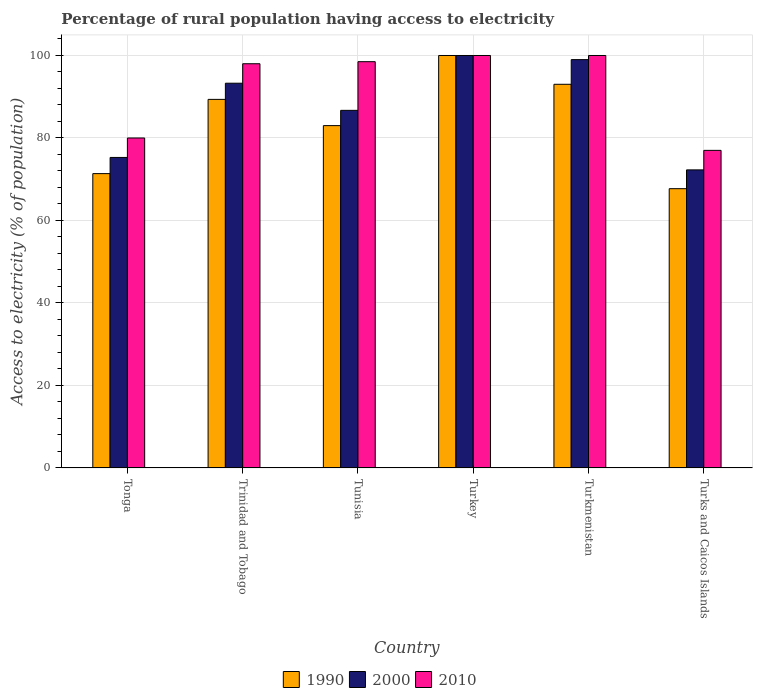How many different coloured bars are there?
Make the answer very short. 3. How many groups of bars are there?
Your answer should be very brief. 6. Are the number of bars per tick equal to the number of legend labels?
Offer a terse response. Yes. Are the number of bars on each tick of the X-axis equal?
Offer a terse response. Yes. What is the label of the 4th group of bars from the left?
Ensure brevity in your answer.  Turkey. In how many cases, is the number of bars for a given country not equal to the number of legend labels?
Your response must be concise. 0. What is the percentage of rural population having access to electricity in 1990 in Tunisia?
Offer a terse response. 83. Across all countries, what is the maximum percentage of rural population having access to electricity in 2010?
Make the answer very short. 100. Across all countries, what is the minimum percentage of rural population having access to electricity in 1990?
Ensure brevity in your answer.  67.71. In which country was the percentage of rural population having access to electricity in 1990 maximum?
Your answer should be very brief. Turkey. In which country was the percentage of rural population having access to electricity in 1990 minimum?
Your answer should be compact. Turks and Caicos Islands. What is the total percentage of rural population having access to electricity in 1990 in the graph?
Make the answer very short. 504.45. What is the difference between the percentage of rural population having access to electricity in 1990 in Tunisia and that in Turks and Caicos Islands?
Give a very brief answer. 15.29. What is the difference between the percentage of rural population having access to electricity in 2000 in Turks and Caicos Islands and the percentage of rural population having access to electricity in 1990 in Tonga?
Make the answer very short. 0.9. What is the average percentage of rural population having access to electricity in 2010 per country?
Offer a terse response. 92.25. In how many countries, is the percentage of rural population having access to electricity in 2010 greater than 96 %?
Your response must be concise. 4. What is the ratio of the percentage of rural population having access to electricity in 1990 in Tunisia to that in Turkey?
Keep it short and to the point. 0.83. Is the percentage of rural population having access to electricity in 1990 in Tunisia less than that in Turkmenistan?
Keep it short and to the point. Yes. What is the difference between the highest and the second highest percentage of rural population having access to electricity in 2010?
Keep it short and to the point. -1.5. In how many countries, is the percentage of rural population having access to electricity in 2000 greater than the average percentage of rural population having access to electricity in 2000 taken over all countries?
Provide a short and direct response. 3. Is the sum of the percentage of rural population having access to electricity in 2010 in Trinidad and Tobago and Tunisia greater than the maximum percentage of rural population having access to electricity in 2000 across all countries?
Make the answer very short. Yes. What does the 1st bar from the left in Tonga represents?
Make the answer very short. 1990. What does the 2nd bar from the right in Turkey represents?
Your answer should be compact. 2000. Is it the case that in every country, the sum of the percentage of rural population having access to electricity in 2000 and percentage of rural population having access to electricity in 2010 is greater than the percentage of rural population having access to electricity in 1990?
Ensure brevity in your answer.  Yes. Where does the legend appear in the graph?
Offer a terse response. Bottom center. How many legend labels are there?
Provide a short and direct response. 3. How are the legend labels stacked?
Offer a terse response. Horizontal. What is the title of the graph?
Provide a short and direct response. Percentage of rural population having access to electricity. What is the label or title of the X-axis?
Your response must be concise. Country. What is the label or title of the Y-axis?
Keep it short and to the point. Access to electricity (% of population). What is the Access to electricity (% of population) in 1990 in Tonga?
Your answer should be very brief. 71.36. What is the Access to electricity (% of population) of 2000 in Tonga?
Offer a terse response. 75.28. What is the Access to electricity (% of population) in 1990 in Trinidad and Tobago?
Give a very brief answer. 89.36. What is the Access to electricity (% of population) in 2000 in Trinidad and Tobago?
Your answer should be compact. 93.28. What is the Access to electricity (% of population) in 2010 in Trinidad and Tobago?
Give a very brief answer. 98. What is the Access to electricity (% of population) in 1990 in Tunisia?
Offer a terse response. 83. What is the Access to electricity (% of population) of 2000 in Tunisia?
Give a very brief answer. 86.7. What is the Access to electricity (% of population) in 2010 in Tunisia?
Your response must be concise. 98.5. What is the Access to electricity (% of population) of 2010 in Turkey?
Offer a very short reply. 100. What is the Access to electricity (% of population) in 1990 in Turkmenistan?
Give a very brief answer. 93.02. What is the Access to electricity (% of population) of 1990 in Turks and Caicos Islands?
Provide a succinct answer. 67.71. What is the Access to electricity (% of population) in 2000 in Turks and Caicos Islands?
Offer a terse response. 72.27. Across all countries, what is the maximum Access to electricity (% of population) of 1990?
Offer a terse response. 100. Across all countries, what is the maximum Access to electricity (% of population) in 2010?
Keep it short and to the point. 100. Across all countries, what is the minimum Access to electricity (% of population) in 1990?
Offer a very short reply. 67.71. Across all countries, what is the minimum Access to electricity (% of population) in 2000?
Offer a terse response. 72.27. What is the total Access to electricity (% of population) of 1990 in the graph?
Your answer should be compact. 504.45. What is the total Access to electricity (% of population) of 2000 in the graph?
Give a very brief answer. 526.53. What is the total Access to electricity (% of population) in 2010 in the graph?
Your answer should be very brief. 553.5. What is the difference between the Access to electricity (% of population) of 2000 in Tonga and that in Trinidad and Tobago?
Your response must be concise. -18. What is the difference between the Access to electricity (% of population) of 2010 in Tonga and that in Trinidad and Tobago?
Your answer should be very brief. -18. What is the difference between the Access to electricity (% of population) in 1990 in Tonga and that in Tunisia?
Ensure brevity in your answer.  -11.64. What is the difference between the Access to electricity (% of population) in 2000 in Tonga and that in Tunisia?
Keep it short and to the point. -11.42. What is the difference between the Access to electricity (% of population) in 2010 in Tonga and that in Tunisia?
Your answer should be very brief. -18.5. What is the difference between the Access to electricity (% of population) of 1990 in Tonga and that in Turkey?
Ensure brevity in your answer.  -28.64. What is the difference between the Access to electricity (% of population) of 2000 in Tonga and that in Turkey?
Provide a short and direct response. -24.72. What is the difference between the Access to electricity (% of population) of 2010 in Tonga and that in Turkey?
Offer a very short reply. -20. What is the difference between the Access to electricity (% of population) of 1990 in Tonga and that in Turkmenistan?
Provide a short and direct response. -21.66. What is the difference between the Access to electricity (% of population) in 2000 in Tonga and that in Turkmenistan?
Give a very brief answer. -23.72. What is the difference between the Access to electricity (% of population) in 2010 in Tonga and that in Turkmenistan?
Ensure brevity in your answer.  -20. What is the difference between the Access to electricity (% of population) in 1990 in Tonga and that in Turks and Caicos Islands?
Offer a terse response. 3.65. What is the difference between the Access to electricity (% of population) of 2000 in Tonga and that in Turks and Caicos Islands?
Ensure brevity in your answer.  3.02. What is the difference between the Access to electricity (% of population) of 1990 in Trinidad and Tobago and that in Tunisia?
Offer a terse response. 6.36. What is the difference between the Access to electricity (% of population) in 2000 in Trinidad and Tobago and that in Tunisia?
Offer a terse response. 6.58. What is the difference between the Access to electricity (% of population) of 2010 in Trinidad and Tobago and that in Tunisia?
Provide a short and direct response. -0.5. What is the difference between the Access to electricity (% of population) of 1990 in Trinidad and Tobago and that in Turkey?
Offer a terse response. -10.64. What is the difference between the Access to electricity (% of population) in 2000 in Trinidad and Tobago and that in Turkey?
Make the answer very short. -6.72. What is the difference between the Access to electricity (% of population) of 1990 in Trinidad and Tobago and that in Turkmenistan?
Offer a terse response. -3.66. What is the difference between the Access to electricity (% of population) in 2000 in Trinidad and Tobago and that in Turkmenistan?
Make the answer very short. -5.72. What is the difference between the Access to electricity (% of population) in 2010 in Trinidad and Tobago and that in Turkmenistan?
Ensure brevity in your answer.  -2. What is the difference between the Access to electricity (% of population) in 1990 in Trinidad and Tobago and that in Turks and Caicos Islands?
Offer a terse response. 21.65. What is the difference between the Access to electricity (% of population) of 2000 in Trinidad and Tobago and that in Turks and Caicos Islands?
Your response must be concise. 21.02. What is the difference between the Access to electricity (% of population) in 2010 in Trinidad and Tobago and that in Turks and Caicos Islands?
Your answer should be very brief. 21. What is the difference between the Access to electricity (% of population) of 2010 in Tunisia and that in Turkey?
Provide a succinct answer. -1.5. What is the difference between the Access to electricity (% of population) in 1990 in Tunisia and that in Turkmenistan?
Offer a terse response. -10.02. What is the difference between the Access to electricity (% of population) of 2000 in Tunisia and that in Turkmenistan?
Keep it short and to the point. -12.3. What is the difference between the Access to electricity (% of population) in 2010 in Tunisia and that in Turkmenistan?
Offer a very short reply. -1.5. What is the difference between the Access to electricity (% of population) in 1990 in Tunisia and that in Turks and Caicos Islands?
Give a very brief answer. 15.29. What is the difference between the Access to electricity (% of population) of 2000 in Tunisia and that in Turks and Caicos Islands?
Provide a succinct answer. 14.44. What is the difference between the Access to electricity (% of population) of 1990 in Turkey and that in Turkmenistan?
Keep it short and to the point. 6.98. What is the difference between the Access to electricity (% of population) in 1990 in Turkey and that in Turks and Caicos Islands?
Keep it short and to the point. 32.29. What is the difference between the Access to electricity (% of population) of 2000 in Turkey and that in Turks and Caicos Islands?
Your response must be concise. 27.73. What is the difference between the Access to electricity (% of population) of 2010 in Turkey and that in Turks and Caicos Islands?
Make the answer very short. 23. What is the difference between the Access to electricity (% of population) of 1990 in Turkmenistan and that in Turks and Caicos Islands?
Provide a short and direct response. 25.31. What is the difference between the Access to electricity (% of population) of 2000 in Turkmenistan and that in Turks and Caicos Islands?
Ensure brevity in your answer.  26.73. What is the difference between the Access to electricity (% of population) of 1990 in Tonga and the Access to electricity (% of population) of 2000 in Trinidad and Tobago?
Make the answer very short. -21.92. What is the difference between the Access to electricity (% of population) of 1990 in Tonga and the Access to electricity (% of population) of 2010 in Trinidad and Tobago?
Give a very brief answer. -26.64. What is the difference between the Access to electricity (% of population) of 2000 in Tonga and the Access to electricity (% of population) of 2010 in Trinidad and Tobago?
Provide a succinct answer. -22.72. What is the difference between the Access to electricity (% of population) in 1990 in Tonga and the Access to electricity (% of population) in 2000 in Tunisia?
Provide a short and direct response. -15.34. What is the difference between the Access to electricity (% of population) in 1990 in Tonga and the Access to electricity (% of population) in 2010 in Tunisia?
Provide a succinct answer. -27.14. What is the difference between the Access to electricity (% of population) in 2000 in Tonga and the Access to electricity (% of population) in 2010 in Tunisia?
Keep it short and to the point. -23.22. What is the difference between the Access to electricity (% of population) of 1990 in Tonga and the Access to electricity (% of population) of 2000 in Turkey?
Keep it short and to the point. -28.64. What is the difference between the Access to electricity (% of population) of 1990 in Tonga and the Access to electricity (% of population) of 2010 in Turkey?
Offer a terse response. -28.64. What is the difference between the Access to electricity (% of population) of 2000 in Tonga and the Access to electricity (% of population) of 2010 in Turkey?
Give a very brief answer. -24.72. What is the difference between the Access to electricity (% of population) in 1990 in Tonga and the Access to electricity (% of population) in 2000 in Turkmenistan?
Offer a terse response. -27.64. What is the difference between the Access to electricity (% of population) of 1990 in Tonga and the Access to electricity (% of population) of 2010 in Turkmenistan?
Ensure brevity in your answer.  -28.64. What is the difference between the Access to electricity (% of population) in 2000 in Tonga and the Access to electricity (% of population) in 2010 in Turkmenistan?
Keep it short and to the point. -24.72. What is the difference between the Access to electricity (% of population) of 1990 in Tonga and the Access to electricity (% of population) of 2000 in Turks and Caicos Islands?
Make the answer very short. -0.9. What is the difference between the Access to electricity (% of population) of 1990 in Tonga and the Access to electricity (% of population) of 2010 in Turks and Caicos Islands?
Provide a succinct answer. -5.64. What is the difference between the Access to electricity (% of population) in 2000 in Tonga and the Access to electricity (% of population) in 2010 in Turks and Caicos Islands?
Make the answer very short. -1.72. What is the difference between the Access to electricity (% of population) in 1990 in Trinidad and Tobago and the Access to electricity (% of population) in 2000 in Tunisia?
Provide a short and direct response. 2.66. What is the difference between the Access to electricity (% of population) of 1990 in Trinidad and Tobago and the Access to electricity (% of population) of 2010 in Tunisia?
Your response must be concise. -9.14. What is the difference between the Access to electricity (% of population) of 2000 in Trinidad and Tobago and the Access to electricity (% of population) of 2010 in Tunisia?
Make the answer very short. -5.22. What is the difference between the Access to electricity (% of population) in 1990 in Trinidad and Tobago and the Access to electricity (% of population) in 2000 in Turkey?
Your response must be concise. -10.64. What is the difference between the Access to electricity (% of population) of 1990 in Trinidad and Tobago and the Access to electricity (% of population) of 2010 in Turkey?
Provide a succinct answer. -10.64. What is the difference between the Access to electricity (% of population) of 2000 in Trinidad and Tobago and the Access to electricity (% of population) of 2010 in Turkey?
Keep it short and to the point. -6.72. What is the difference between the Access to electricity (% of population) in 1990 in Trinidad and Tobago and the Access to electricity (% of population) in 2000 in Turkmenistan?
Your answer should be very brief. -9.64. What is the difference between the Access to electricity (% of population) in 1990 in Trinidad and Tobago and the Access to electricity (% of population) in 2010 in Turkmenistan?
Keep it short and to the point. -10.64. What is the difference between the Access to electricity (% of population) in 2000 in Trinidad and Tobago and the Access to electricity (% of population) in 2010 in Turkmenistan?
Ensure brevity in your answer.  -6.72. What is the difference between the Access to electricity (% of population) of 1990 in Trinidad and Tobago and the Access to electricity (% of population) of 2000 in Turks and Caicos Islands?
Your response must be concise. 17.1. What is the difference between the Access to electricity (% of population) in 1990 in Trinidad and Tobago and the Access to electricity (% of population) in 2010 in Turks and Caicos Islands?
Your response must be concise. 12.36. What is the difference between the Access to electricity (% of population) in 2000 in Trinidad and Tobago and the Access to electricity (% of population) in 2010 in Turks and Caicos Islands?
Make the answer very short. 16.28. What is the difference between the Access to electricity (% of population) of 1990 in Tunisia and the Access to electricity (% of population) of 2010 in Turkmenistan?
Give a very brief answer. -17. What is the difference between the Access to electricity (% of population) in 1990 in Tunisia and the Access to electricity (% of population) in 2000 in Turks and Caicos Islands?
Keep it short and to the point. 10.73. What is the difference between the Access to electricity (% of population) of 1990 in Turkey and the Access to electricity (% of population) of 2000 in Turkmenistan?
Your response must be concise. 1. What is the difference between the Access to electricity (% of population) of 2000 in Turkey and the Access to electricity (% of population) of 2010 in Turkmenistan?
Your answer should be very brief. 0. What is the difference between the Access to electricity (% of population) of 1990 in Turkey and the Access to electricity (% of population) of 2000 in Turks and Caicos Islands?
Make the answer very short. 27.73. What is the difference between the Access to electricity (% of population) in 1990 in Turkey and the Access to electricity (% of population) in 2010 in Turks and Caicos Islands?
Offer a terse response. 23. What is the difference between the Access to electricity (% of population) in 2000 in Turkey and the Access to electricity (% of population) in 2010 in Turks and Caicos Islands?
Your answer should be compact. 23. What is the difference between the Access to electricity (% of population) in 1990 in Turkmenistan and the Access to electricity (% of population) in 2000 in Turks and Caicos Islands?
Ensure brevity in your answer.  20.75. What is the difference between the Access to electricity (% of population) of 1990 in Turkmenistan and the Access to electricity (% of population) of 2010 in Turks and Caicos Islands?
Your answer should be compact. 16.02. What is the average Access to electricity (% of population) of 1990 per country?
Make the answer very short. 84.08. What is the average Access to electricity (% of population) of 2000 per country?
Give a very brief answer. 87.75. What is the average Access to electricity (% of population) of 2010 per country?
Offer a very short reply. 92.25. What is the difference between the Access to electricity (% of population) in 1990 and Access to electricity (% of population) in 2000 in Tonga?
Your response must be concise. -3.92. What is the difference between the Access to electricity (% of population) in 1990 and Access to electricity (% of population) in 2010 in Tonga?
Offer a very short reply. -8.64. What is the difference between the Access to electricity (% of population) of 2000 and Access to electricity (% of population) of 2010 in Tonga?
Make the answer very short. -4.72. What is the difference between the Access to electricity (% of population) in 1990 and Access to electricity (% of population) in 2000 in Trinidad and Tobago?
Offer a terse response. -3.92. What is the difference between the Access to electricity (% of population) in 1990 and Access to electricity (% of population) in 2010 in Trinidad and Tobago?
Give a very brief answer. -8.64. What is the difference between the Access to electricity (% of population) in 2000 and Access to electricity (% of population) in 2010 in Trinidad and Tobago?
Provide a short and direct response. -4.72. What is the difference between the Access to electricity (% of population) in 1990 and Access to electricity (% of population) in 2000 in Tunisia?
Provide a succinct answer. -3.7. What is the difference between the Access to electricity (% of population) of 1990 and Access to electricity (% of population) of 2010 in Tunisia?
Ensure brevity in your answer.  -15.5. What is the difference between the Access to electricity (% of population) of 2000 and Access to electricity (% of population) of 2010 in Tunisia?
Give a very brief answer. -11.8. What is the difference between the Access to electricity (% of population) in 2000 and Access to electricity (% of population) in 2010 in Turkey?
Give a very brief answer. 0. What is the difference between the Access to electricity (% of population) of 1990 and Access to electricity (% of population) of 2000 in Turkmenistan?
Provide a short and direct response. -5.98. What is the difference between the Access to electricity (% of population) in 1990 and Access to electricity (% of population) in 2010 in Turkmenistan?
Your response must be concise. -6.98. What is the difference between the Access to electricity (% of population) of 2000 and Access to electricity (% of population) of 2010 in Turkmenistan?
Give a very brief answer. -1. What is the difference between the Access to electricity (% of population) in 1990 and Access to electricity (% of population) in 2000 in Turks and Caicos Islands?
Your answer should be very brief. -4.55. What is the difference between the Access to electricity (% of population) in 1990 and Access to electricity (% of population) in 2010 in Turks and Caicos Islands?
Ensure brevity in your answer.  -9.29. What is the difference between the Access to electricity (% of population) of 2000 and Access to electricity (% of population) of 2010 in Turks and Caicos Islands?
Offer a terse response. -4.74. What is the ratio of the Access to electricity (% of population) in 1990 in Tonga to that in Trinidad and Tobago?
Your response must be concise. 0.8. What is the ratio of the Access to electricity (% of population) of 2000 in Tonga to that in Trinidad and Tobago?
Provide a short and direct response. 0.81. What is the ratio of the Access to electricity (% of population) of 2010 in Tonga to that in Trinidad and Tobago?
Provide a succinct answer. 0.82. What is the ratio of the Access to electricity (% of population) of 1990 in Tonga to that in Tunisia?
Offer a terse response. 0.86. What is the ratio of the Access to electricity (% of population) of 2000 in Tonga to that in Tunisia?
Provide a succinct answer. 0.87. What is the ratio of the Access to electricity (% of population) in 2010 in Tonga to that in Tunisia?
Your answer should be compact. 0.81. What is the ratio of the Access to electricity (% of population) in 1990 in Tonga to that in Turkey?
Provide a succinct answer. 0.71. What is the ratio of the Access to electricity (% of population) of 2000 in Tonga to that in Turkey?
Provide a short and direct response. 0.75. What is the ratio of the Access to electricity (% of population) of 1990 in Tonga to that in Turkmenistan?
Your answer should be very brief. 0.77. What is the ratio of the Access to electricity (% of population) of 2000 in Tonga to that in Turkmenistan?
Offer a terse response. 0.76. What is the ratio of the Access to electricity (% of population) in 2010 in Tonga to that in Turkmenistan?
Offer a terse response. 0.8. What is the ratio of the Access to electricity (% of population) of 1990 in Tonga to that in Turks and Caicos Islands?
Your answer should be very brief. 1.05. What is the ratio of the Access to electricity (% of population) of 2000 in Tonga to that in Turks and Caicos Islands?
Provide a short and direct response. 1.04. What is the ratio of the Access to electricity (% of population) in 2010 in Tonga to that in Turks and Caicos Islands?
Give a very brief answer. 1.04. What is the ratio of the Access to electricity (% of population) of 1990 in Trinidad and Tobago to that in Tunisia?
Provide a succinct answer. 1.08. What is the ratio of the Access to electricity (% of population) in 2000 in Trinidad and Tobago to that in Tunisia?
Make the answer very short. 1.08. What is the ratio of the Access to electricity (% of population) in 2010 in Trinidad and Tobago to that in Tunisia?
Keep it short and to the point. 0.99. What is the ratio of the Access to electricity (% of population) of 1990 in Trinidad and Tobago to that in Turkey?
Your answer should be compact. 0.89. What is the ratio of the Access to electricity (% of population) of 2000 in Trinidad and Tobago to that in Turkey?
Offer a very short reply. 0.93. What is the ratio of the Access to electricity (% of population) of 2010 in Trinidad and Tobago to that in Turkey?
Provide a short and direct response. 0.98. What is the ratio of the Access to electricity (% of population) in 1990 in Trinidad and Tobago to that in Turkmenistan?
Give a very brief answer. 0.96. What is the ratio of the Access to electricity (% of population) of 2000 in Trinidad and Tobago to that in Turkmenistan?
Provide a succinct answer. 0.94. What is the ratio of the Access to electricity (% of population) in 1990 in Trinidad and Tobago to that in Turks and Caicos Islands?
Your response must be concise. 1.32. What is the ratio of the Access to electricity (% of population) in 2000 in Trinidad and Tobago to that in Turks and Caicos Islands?
Give a very brief answer. 1.29. What is the ratio of the Access to electricity (% of population) of 2010 in Trinidad and Tobago to that in Turks and Caicos Islands?
Offer a very short reply. 1.27. What is the ratio of the Access to electricity (% of population) of 1990 in Tunisia to that in Turkey?
Provide a short and direct response. 0.83. What is the ratio of the Access to electricity (% of population) in 2000 in Tunisia to that in Turkey?
Offer a very short reply. 0.87. What is the ratio of the Access to electricity (% of population) in 2010 in Tunisia to that in Turkey?
Your answer should be compact. 0.98. What is the ratio of the Access to electricity (% of population) in 1990 in Tunisia to that in Turkmenistan?
Offer a very short reply. 0.89. What is the ratio of the Access to electricity (% of population) of 2000 in Tunisia to that in Turkmenistan?
Make the answer very short. 0.88. What is the ratio of the Access to electricity (% of population) in 2010 in Tunisia to that in Turkmenistan?
Make the answer very short. 0.98. What is the ratio of the Access to electricity (% of population) in 1990 in Tunisia to that in Turks and Caicos Islands?
Keep it short and to the point. 1.23. What is the ratio of the Access to electricity (% of population) in 2000 in Tunisia to that in Turks and Caicos Islands?
Provide a succinct answer. 1.2. What is the ratio of the Access to electricity (% of population) of 2010 in Tunisia to that in Turks and Caicos Islands?
Keep it short and to the point. 1.28. What is the ratio of the Access to electricity (% of population) of 1990 in Turkey to that in Turkmenistan?
Ensure brevity in your answer.  1.07. What is the ratio of the Access to electricity (% of population) of 1990 in Turkey to that in Turks and Caicos Islands?
Your response must be concise. 1.48. What is the ratio of the Access to electricity (% of population) of 2000 in Turkey to that in Turks and Caicos Islands?
Your answer should be compact. 1.38. What is the ratio of the Access to electricity (% of population) of 2010 in Turkey to that in Turks and Caicos Islands?
Offer a terse response. 1.3. What is the ratio of the Access to electricity (% of population) in 1990 in Turkmenistan to that in Turks and Caicos Islands?
Your answer should be compact. 1.37. What is the ratio of the Access to electricity (% of population) in 2000 in Turkmenistan to that in Turks and Caicos Islands?
Offer a very short reply. 1.37. What is the ratio of the Access to electricity (% of population) in 2010 in Turkmenistan to that in Turks and Caicos Islands?
Ensure brevity in your answer.  1.3. What is the difference between the highest and the second highest Access to electricity (% of population) of 1990?
Your response must be concise. 6.98. What is the difference between the highest and the second highest Access to electricity (% of population) in 2000?
Ensure brevity in your answer.  1. What is the difference between the highest and the lowest Access to electricity (% of population) in 1990?
Make the answer very short. 32.29. What is the difference between the highest and the lowest Access to electricity (% of population) in 2000?
Your answer should be very brief. 27.73. 